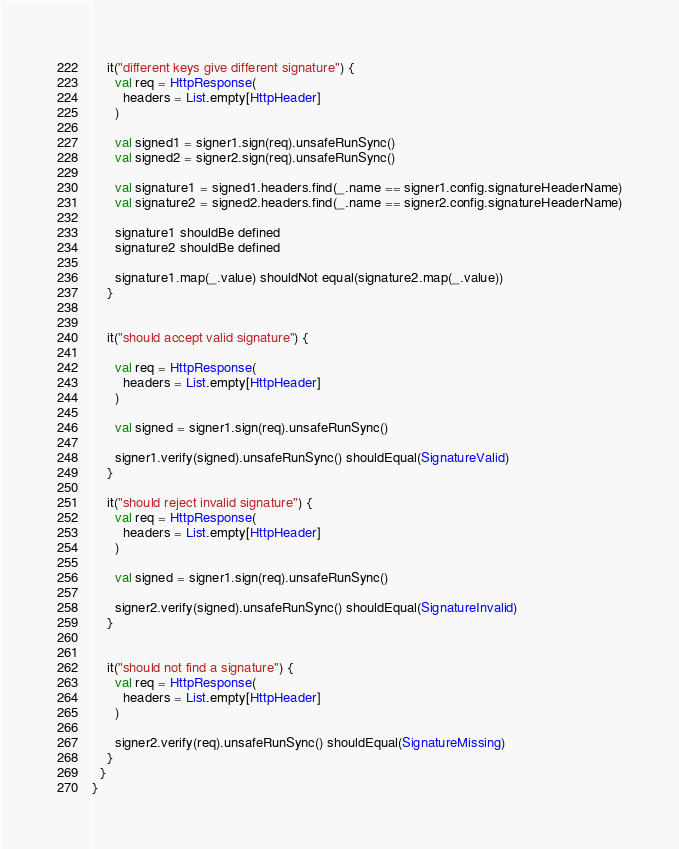<code> <loc_0><loc_0><loc_500><loc_500><_Scala_>
    it("different keys give different signature") {
      val req = HttpResponse(
        headers = List.empty[HttpHeader]
      )

      val signed1 = signer1.sign(req).unsafeRunSync()
      val signed2 = signer2.sign(req).unsafeRunSync()

      val signature1 = signed1.headers.find(_.name == signer1.config.signatureHeaderName)
      val signature2 = signed2.headers.find(_.name == signer2.config.signatureHeaderName)

      signature1 shouldBe defined
      signature2 shouldBe defined

      signature1.map(_.value) shouldNot equal(signature2.map(_.value))
    }


    it("should accept valid signature") {

      val req = HttpResponse(
        headers = List.empty[HttpHeader]
      )

      val signed = signer1.sign(req).unsafeRunSync()

      signer1.verify(signed).unsafeRunSync() shouldEqual(SignatureValid)
    }

    it("should reject invalid signature") {
      val req = HttpResponse(
        headers = List.empty[HttpHeader]
      )

      val signed = signer1.sign(req).unsafeRunSync()

      signer2.verify(signed).unsafeRunSync() shouldEqual(SignatureInvalid)
    }


    it("should not find a signature") {
      val req = HttpResponse(
        headers = List.empty[HttpHeader]
      )

      signer2.verify(req).unsafeRunSync() shouldEqual(SignatureMissing)
    }
  }
}
</code> 